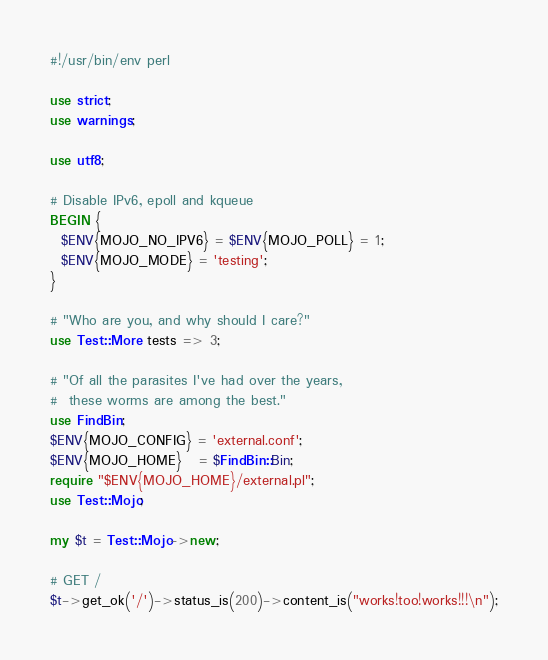<code> <loc_0><loc_0><loc_500><loc_500><_Perl_>#!/usr/bin/env perl

use strict;
use warnings;

use utf8;

# Disable IPv6, epoll and kqueue
BEGIN {
  $ENV{MOJO_NO_IPV6} = $ENV{MOJO_POLL} = 1;
  $ENV{MOJO_MODE} = 'testing';
}

# "Who are you, and why should I care?"
use Test::More tests => 3;

# "Of all the parasites I've had over the years,
#  these worms are among the best."
use FindBin;
$ENV{MOJO_CONFIG} = 'external.conf';
$ENV{MOJO_HOME}   = $FindBin::Bin;
require "$ENV{MOJO_HOME}/external.pl";
use Test::Mojo;

my $t = Test::Mojo->new;

# GET /
$t->get_ok('/')->status_is(200)->content_is("works!too!works!!!\n");
</code> 